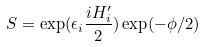Convert formula to latex. <formula><loc_0><loc_0><loc_500><loc_500>S = \exp ( \epsilon _ { i } \frac { i H ^ { \prime } _ { i } } 2 ) \exp ( - \phi / 2 )</formula> 